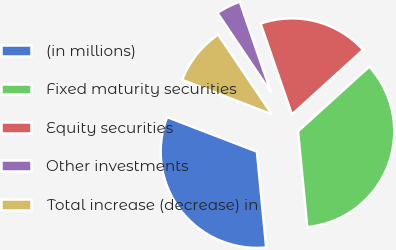<chart> <loc_0><loc_0><loc_500><loc_500><pie_chart><fcel>(in millions)<fcel>Fixed maturity securities<fcel>Equity securities<fcel>Other investments<fcel>Total increase (decrease) in<nl><fcel>32.38%<fcel>35.2%<fcel>18.55%<fcel>4.16%<fcel>9.72%<nl></chart> 